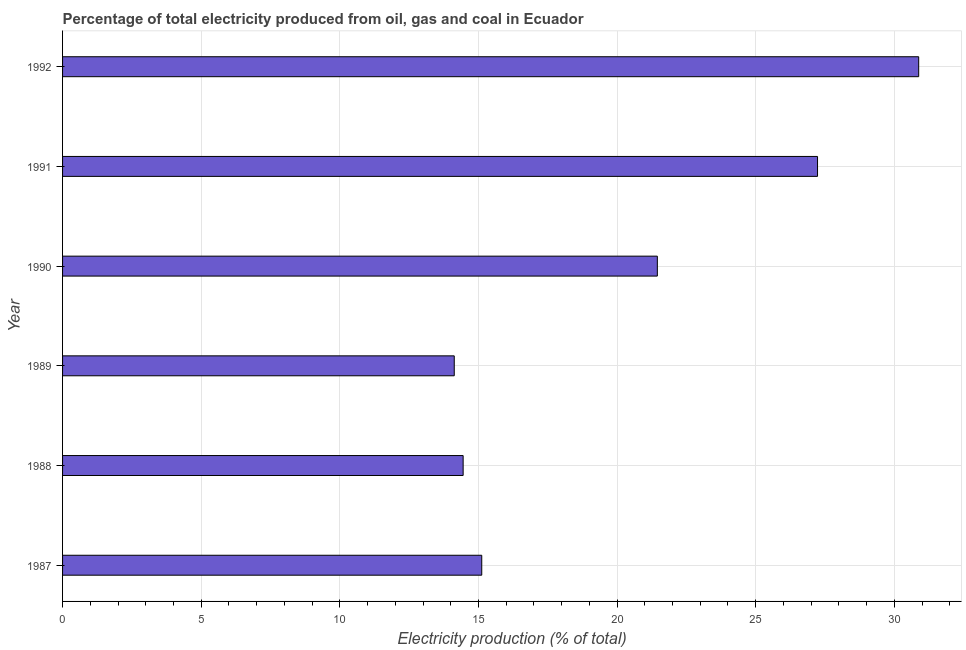Does the graph contain any zero values?
Provide a succinct answer. No. What is the title of the graph?
Your answer should be compact. Percentage of total electricity produced from oil, gas and coal in Ecuador. What is the label or title of the X-axis?
Your response must be concise. Electricity production (% of total). What is the label or title of the Y-axis?
Offer a very short reply. Year. What is the electricity production in 1992?
Keep it short and to the point. 30.88. Across all years, what is the maximum electricity production?
Ensure brevity in your answer.  30.88. Across all years, what is the minimum electricity production?
Your answer should be very brief. 14.13. What is the sum of the electricity production?
Offer a very short reply. 123.25. What is the difference between the electricity production in 1990 and 1992?
Make the answer very short. -9.43. What is the average electricity production per year?
Offer a terse response. 20.54. What is the median electricity production?
Provide a short and direct response. 18.29. Do a majority of the years between 1990 and 1989 (inclusive) have electricity production greater than 10 %?
Offer a very short reply. No. What is the ratio of the electricity production in 1988 to that in 1990?
Ensure brevity in your answer.  0.67. Is the electricity production in 1989 less than that in 1992?
Keep it short and to the point. Yes. What is the difference between the highest and the second highest electricity production?
Your answer should be compact. 3.65. What is the difference between the highest and the lowest electricity production?
Your answer should be compact. 16.75. What is the difference between two consecutive major ticks on the X-axis?
Provide a succinct answer. 5. What is the Electricity production (% of total) in 1987?
Offer a very short reply. 15.12. What is the Electricity production (% of total) of 1988?
Your response must be concise. 14.45. What is the Electricity production (% of total) in 1989?
Offer a very short reply. 14.13. What is the Electricity production (% of total) in 1990?
Give a very brief answer. 21.45. What is the Electricity production (% of total) of 1991?
Offer a very short reply. 27.23. What is the Electricity production (% of total) in 1992?
Your answer should be compact. 30.88. What is the difference between the Electricity production (% of total) in 1987 and 1988?
Ensure brevity in your answer.  0.67. What is the difference between the Electricity production (% of total) in 1987 and 1989?
Ensure brevity in your answer.  0.99. What is the difference between the Electricity production (% of total) in 1987 and 1990?
Your answer should be very brief. -6.33. What is the difference between the Electricity production (% of total) in 1987 and 1991?
Provide a short and direct response. -12.11. What is the difference between the Electricity production (% of total) in 1987 and 1992?
Provide a succinct answer. -15.76. What is the difference between the Electricity production (% of total) in 1988 and 1989?
Provide a short and direct response. 0.32. What is the difference between the Electricity production (% of total) in 1988 and 1990?
Your answer should be very brief. -7. What is the difference between the Electricity production (% of total) in 1988 and 1991?
Give a very brief answer. -12.78. What is the difference between the Electricity production (% of total) in 1988 and 1992?
Your answer should be very brief. -16.43. What is the difference between the Electricity production (% of total) in 1989 and 1990?
Keep it short and to the point. -7.32. What is the difference between the Electricity production (% of total) in 1989 and 1991?
Your answer should be compact. -13.1. What is the difference between the Electricity production (% of total) in 1989 and 1992?
Keep it short and to the point. -16.75. What is the difference between the Electricity production (% of total) in 1990 and 1991?
Provide a short and direct response. -5.78. What is the difference between the Electricity production (% of total) in 1990 and 1992?
Offer a very short reply. -9.43. What is the difference between the Electricity production (% of total) in 1991 and 1992?
Your answer should be compact. -3.65. What is the ratio of the Electricity production (% of total) in 1987 to that in 1988?
Your answer should be compact. 1.05. What is the ratio of the Electricity production (% of total) in 1987 to that in 1989?
Keep it short and to the point. 1.07. What is the ratio of the Electricity production (% of total) in 1987 to that in 1990?
Your answer should be very brief. 0.7. What is the ratio of the Electricity production (% of total) in 1987 to that in 1991?
Make the answer very short. 0.56. What is the ratio of the Electricity production (% of total) in 1987 to that in 1992?
Offer a very short reply. 0.49. What is the ratio of the Electricity production (% of total) in 1988 to that in 1990?
Give a very brief answer. 0.67. What is the ratio of the Electricity production (% of total) in 1988 to that in 1991?
Provide a succinct answer. 0.53. What is the ratio of the Electricity production (% of total) in 1988 to that in 1992?
Keep it short and to the point. 0.47. What is the ratio of the Electricity production (% of total) in 1989 to that in 1990?
Make the answer very short. 0.66. What is the ratio of the Electricity production (% of total) in 1989 to that in 1991?
Give a very brief answer. 0.52. What is the ratio of the Electricity production (% of total) in 1989 to that in 1992?
Give a very brief answer. 0.46. What is the ratio of the Electricity production (% of total) in 1990 to that in 1991?
Offer a very short reply. 0.79. What is the ratio of the Electricity production (% of total) in 1990 to that in 1992?
Your answer should be compact. 0.69. What is the ratio of the Electricity production (% of total) in 1991 to that in 1992?
Offer a very short reply. 0.88. 